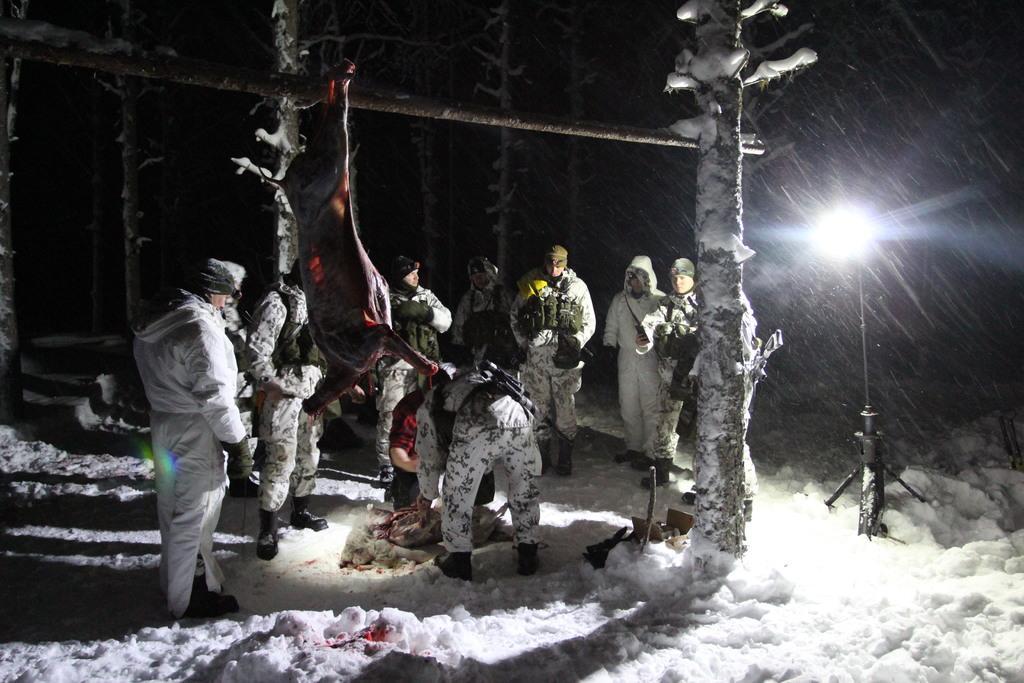In one or two sentences, can you explain what this image depicts? In the center of the image there are persons standing on the snow and we can see meat hanged to the stick. In the background we can see trees and snow. On the right side there is a light. 